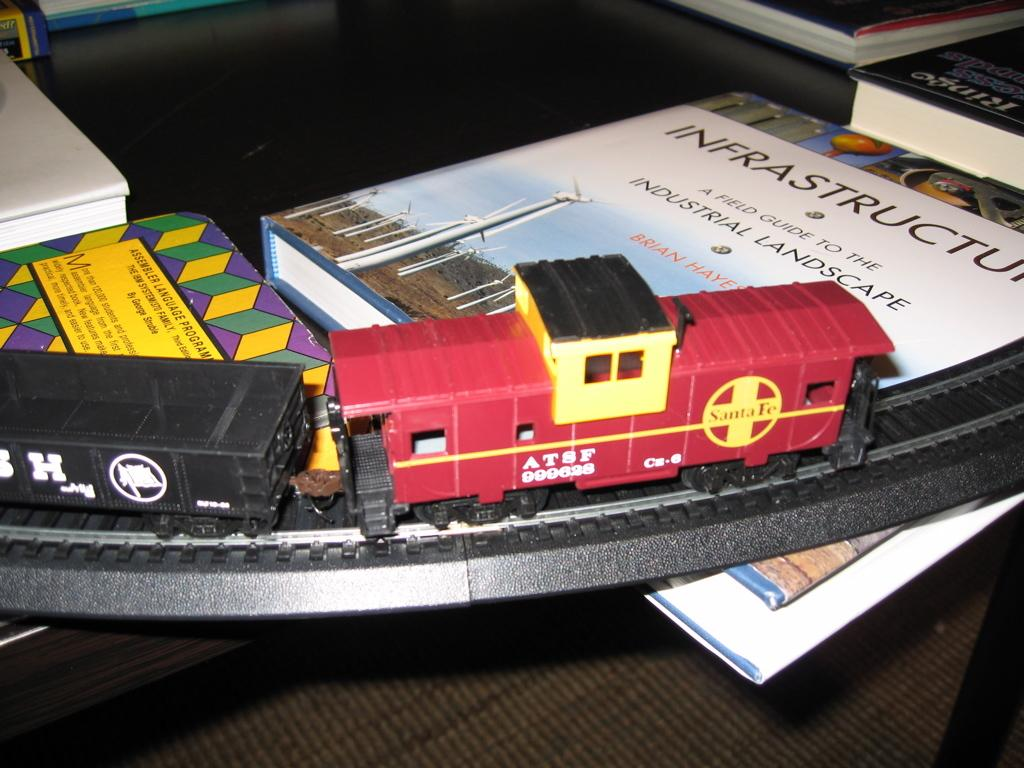<image>
Give a short and clear explanation of the subsequent image. Part of a train set toy is on top of a book entitled INFRASTRUCTURE a field guide to the industrial landscape. 